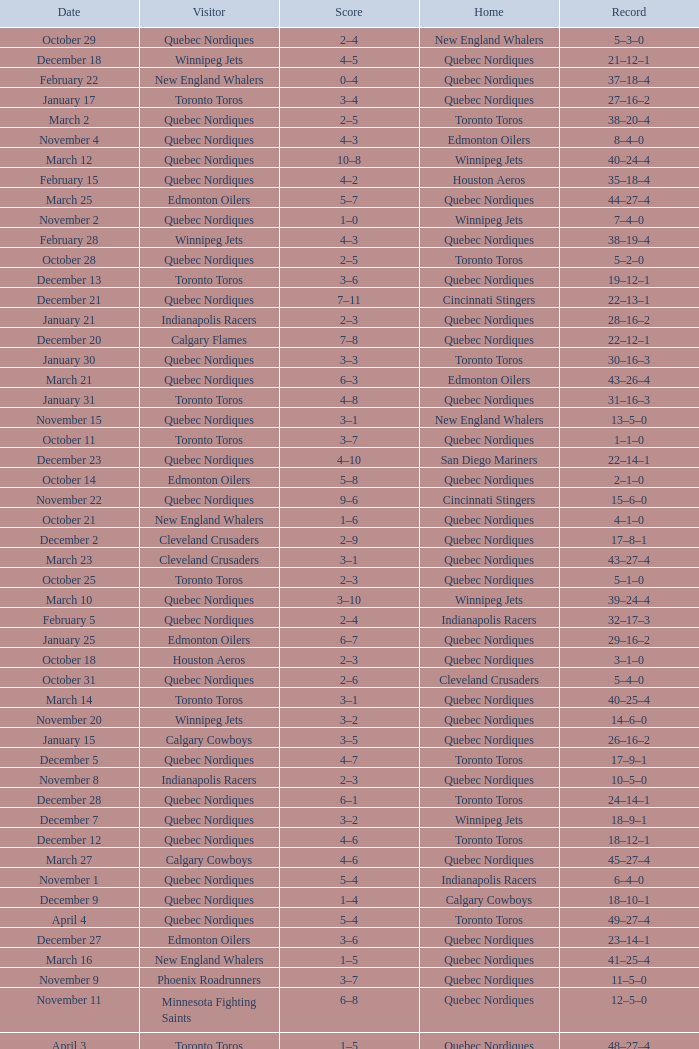I'm looking to parse the entire table for insights. Could you assist me with that? {'header': ['Date', 'Visitor', 'Score', 'Home', 'Record'], 'rows': [['October 29', 'Quebec Nordiques', '2–4', 'New England Whalers', '5–3–0'], ['December 18', 'Winnipeg Jets', '4–5', 'Quebec Nordiques', '21–12–1'], ['February 22', 'New England Whalers', '0–4', 'Quebec Nordiques', '37–18–4'], ['January 17', 'Toronto Toros', '3–4', 'Quebec Nordiques', '27–16–2'], ['March 2', 'Quebec Nordiques', '2–5', 'Toronto Toros', '38–20–4'], ['November 4', 'Quebec Nordiques', '4–3', 'Edmonton Oilers', '8–4–0'], ['March 12', 'Quebec Nordiques', '10–8', 'Winnipeg Jets', '40–24–4'], ['February 15', 'Quebec Nordiques', '4–2', 'Houston Aeros', '35–18–4'], ['March 25', 'Edmonton Oilers', '5–7', 'Quebec Nordiques', '44–27–4'], ['November 2', 'Quebec Nordiques', '1–0', 'Winnipeg Jets', '7–4–0'], ['February 28', 'Winnipeg Jets', '4–3', 'Quebec Nordiques', '38–19–4'], ['October 28', 'Quebec Nordiques', '2–5', 'Toronto Toros', '5–2–0'], ['December 13', 'Toronto Toros', '3–6', 'Quebec Nordiques', '19–12–1'], ['December 21', 'Quebec Nordiques', '7–11', 'Cincinnati Stingers', '22–13–1'], ['January 21', 'Indianapolis Racers', '2–3', 'Quebec Nordiques', '28–16–2'], ['December 20', 'Calgary Flames', '7–8', 'Quebec Nordiques', '22–12–1'], ['January 30', 'Quebec Nordiques', '3–3', 'Toronto Toros', '30–16–3'], ['March 21', 'Quebec Nordiques', '6–3', 'Edmonton Oilers', '43–26–4'], ['January 31', 'Toronto Toros', '4–8', 'Quebec Nordiques', '31–16–3'], ['November 15', 'Quebec Nordiques', '3–1', 'New England Whalers', '13–5–0'], ['October 11', 'Toronto Toros', '3–7', 'Quebec Nordiques', '1–1–0'], ['December 23', 'Quebec Nordiques', '4–10', 'San Diego Mariners', '22–14–1'], ['October 14', 'Edmonton Oilers', '5–8', 'Quebec Nordiques', '2–1–0'], ['November 22', 'Quebec Nordiques', '9–6', 'Cincinnati Stingers', '15–6–0'], ['October 21', 'New England Whalers', '1–6', 'Quebec Nordiques', '4–1–0'], ['December 2', 'Cleveland Crusaders', '2–9', 'Quebec Nordiques', '17–8–1'], ['March 23', 'Cleveland Crusaders', '3–1', 'Quebec Nordiques', '43–27–4'], ['October 25', 'Toronto Toros', '2–3', 'Quebec Nordiques', '5–1–0'], ['March 10', 'Quebec Nordiques', '3–10', 'Winnipeg Jets', '39–24–4'], ['February 5', 'Quebec Nordiques', '2–4', 'Indianapolis Racers', '32–17–3'], ['January 25', 'Edmonton Oilers', '6–7', 'Quebec Nordiques', '29–16–2'], ['October 18', 'Houston Aeros', '2–3', 'Quebec Nordiques', '3–1–0'], ['October 31', 'Quebec Nordiques', '2–6', 'Cleveland Crusaders', '5–4–0'], ['March 14', 'Toronto Toros', '3–1', 'Quebec Nordiques', '40–25–4'], ['November 20', 'Winnipeg Jets', '3–2', 'Quebec Nordiques', '14–6–0'], ['January 15', 'Calgary Cowboys', '3–5', 'Quebec Nordiques', '26–16–2'], ['December 5', 'Quebec Nordiques', '4–7', 'Toronto Toros', '17–9–1'], ['November 8', 'Indianapolis Racers', '2–3', 'Quebec Nordiques', '10–5–0'], ['December 28', 'Quebec Nordiques', '6–1', 'Toronto Toros', '24–14–1'], ['December 7', 'Quebec Nordiques', '3–2', 'Winnipeg Jets', '18–9–1'], ['December 12', 'Quebec Nordiques', '4–6', 'Toronto Toros', '18–12–1'], ['March 27', 'Calgary Cowboys', '4–6', 'Quebec Nordiques', '45–27–4'], ['November 1', 'Quebec Nordiques', '5–4', 'Indianapolis Racers', '6–4–0'], ['December 9', 'Quebec Nordiques', '1–4', 'Calgary Cowboys', '18–10–1'], ['April 4', 'Quebec Nordiques', '5–4', 'Toronto Toros', '49–27–4'], ['December 27', 'Edmonton Oilers', '3–6', 'Quebec Nordiques', '23–14–1'], ['March 16', 'New England Whalers', '1–5', 'Quebec Nordiques', '41–25–4'], ['November 9', 'Phoenix Roadrunners', '3–7', 'Quebec Nordiques', '11–5–0'], ['November 11', 'Minnesota Fighting Saints', '6–8', 'Quebec Nordiques', '12–5–0'], ['April 3', 'Toronto Toros', '1–5', 'Quebec Nordiques', '48–27–4'], ['November 23', 'Quebec Nordiques', '0–4', 'Houston Aeros', '15–7–0'], ['February 24', 'Houston Aeros', '1–4', 'Quebec Nordiques', '38–18–4'], ['January 2', 'Quebec Nordiques', '4–5', 'Cleveland Crusaders', '24–15–2'], ['March 30', 'Edmonton Oilers', '3–8', 'Quebec Nordiques', '46–27–4'], ['February 7', 'Quebec Nordiques', '4–4', 'Calgary Cowboys', '32–17–4'], ['November 18', 'Cincinnati Stingers', '4–6', 'Quebec Nordiques', '14–5–0'], ['October 9', 'Winnipeg Jets', '5–3', 'Quebec Nordiques', '0–1–0'], ['April 6', 'Toronto Toros', '6–10', 'Quebec Nordiques', '50–27–4'], ['January 10', 'San Diego Mariners', '3–4', 'Quebec Nordiques', '25–16–2'], ['March 7', 'Quebec Nordiques', '2–4', 'Edmonton Oilers', '39–22–4'], ['January 3', 'Phoenix Roadrunners', '4–1', 'Quebec Nordiques', '24–16–2'], ['November 6', 'Quebec Nordiques', '5–3', 'Denver Spurs', '9–5–0'], ['November 5', 'Quebec Nordiques', '2–4', 'Calgary Cowboys', '8–5–0'], ['February 11', 'Quebec Nordiques', '6–4', 'Winnipeg Jets', '34–17–4'], ['November 27', 'Quebec Nordiques', '1–5', 'San Diego Mariners', '15–8–0'], ['February 8', 'Quebec Nordiques', '5–4', 'Edmonton Oilers', '33–17–4'], ['November 30', 'Quebec Nordiques', '2–1', 'Phoenix Roadrunners', '16–8–1'], ['March 5', 'Quebec Nordiques', '5–4', 'Edmonton Oilers', '39–21–4'], ['February 12', 'Quebec Nordiques', '4–6', 'Minnesota Fighting Saints', '34–18–4'], ['March 19', 'Quebec Nordiques', '4–3', 'Toronto Toros', '42–25–4'], ['February 17', 'San Diego Mariners', '2–5', 'Quebec Nordiques', '36–18–4'], ['November 29', 'Quebec Nordiques', '4–4', 'Phoenix Roadrunners', '15–8–1'], ['December 10', 'Quebec Nordiques', '4–7', 'Edmonton Oilers', '18–11–1'], ['December 16', 'Calgary Cowboys', '3–7', 'Quebec Nordiques', '20–12–1'], ['March 4', 'Quebec Nordiques', '1–4', 'Calgary Cowboys', '38–21–4'], ['February 3', 'Winnipeg Jets', '4–5', 'Quebec Nordiques', '32–16–3'], ['March 9', 'Quebec Nordiques', '4–7', 'Calgary Cowboys', '39–23–4'], ['March 20', 'Calgary Cowboys', '8–7', 'Quebec Nordiques', '42–26–4'], ['December 30', 'Quebec Nordiques', '4–4', 'Minnesota Fighting Saints', '24–14–2'], ['January 27', 'Cincinnati Stingers', '1–9', 'Quebec Nordiques', '30–16–2'], ['April 1', 'Edmonton Oilers', '2–7', 'Quebec Nordiques', '47–27–4']]} On what date did the 2–1 scored game occur? November 30. 